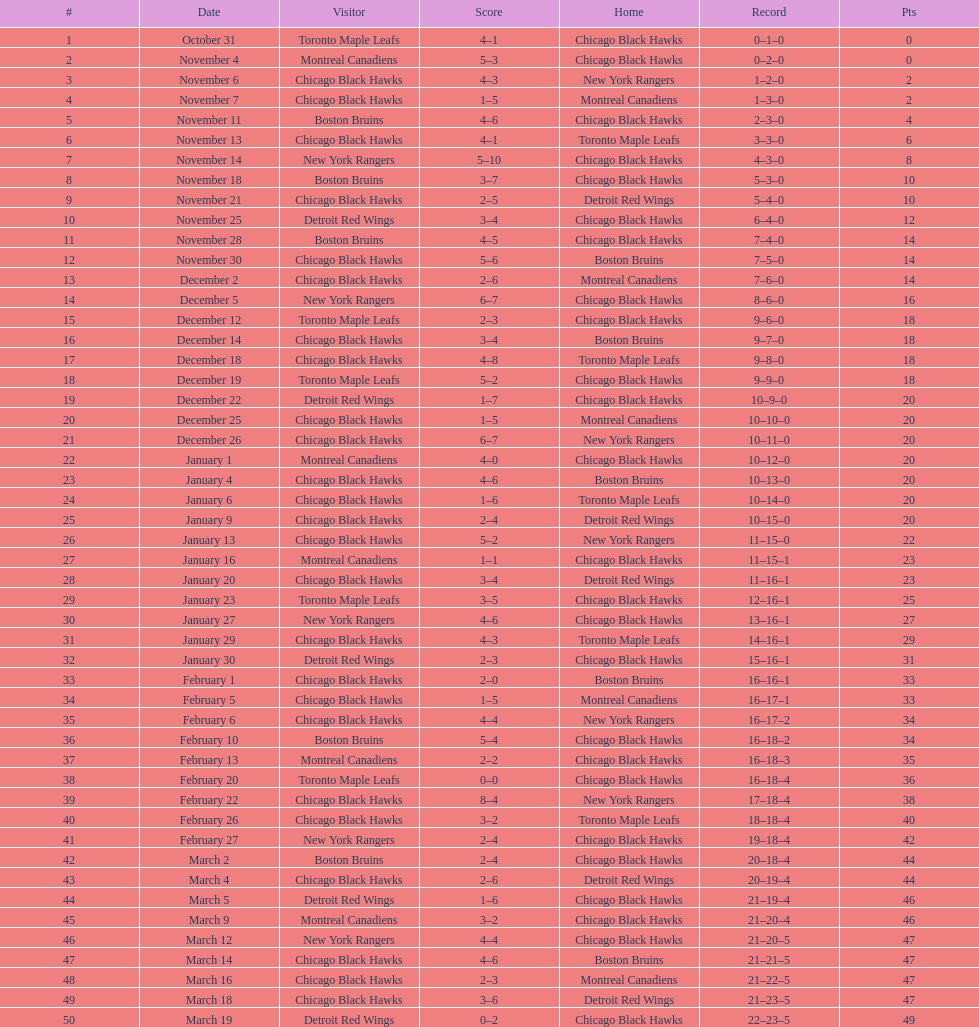What is the difference in pts between december 5th and november 11th? 3. 